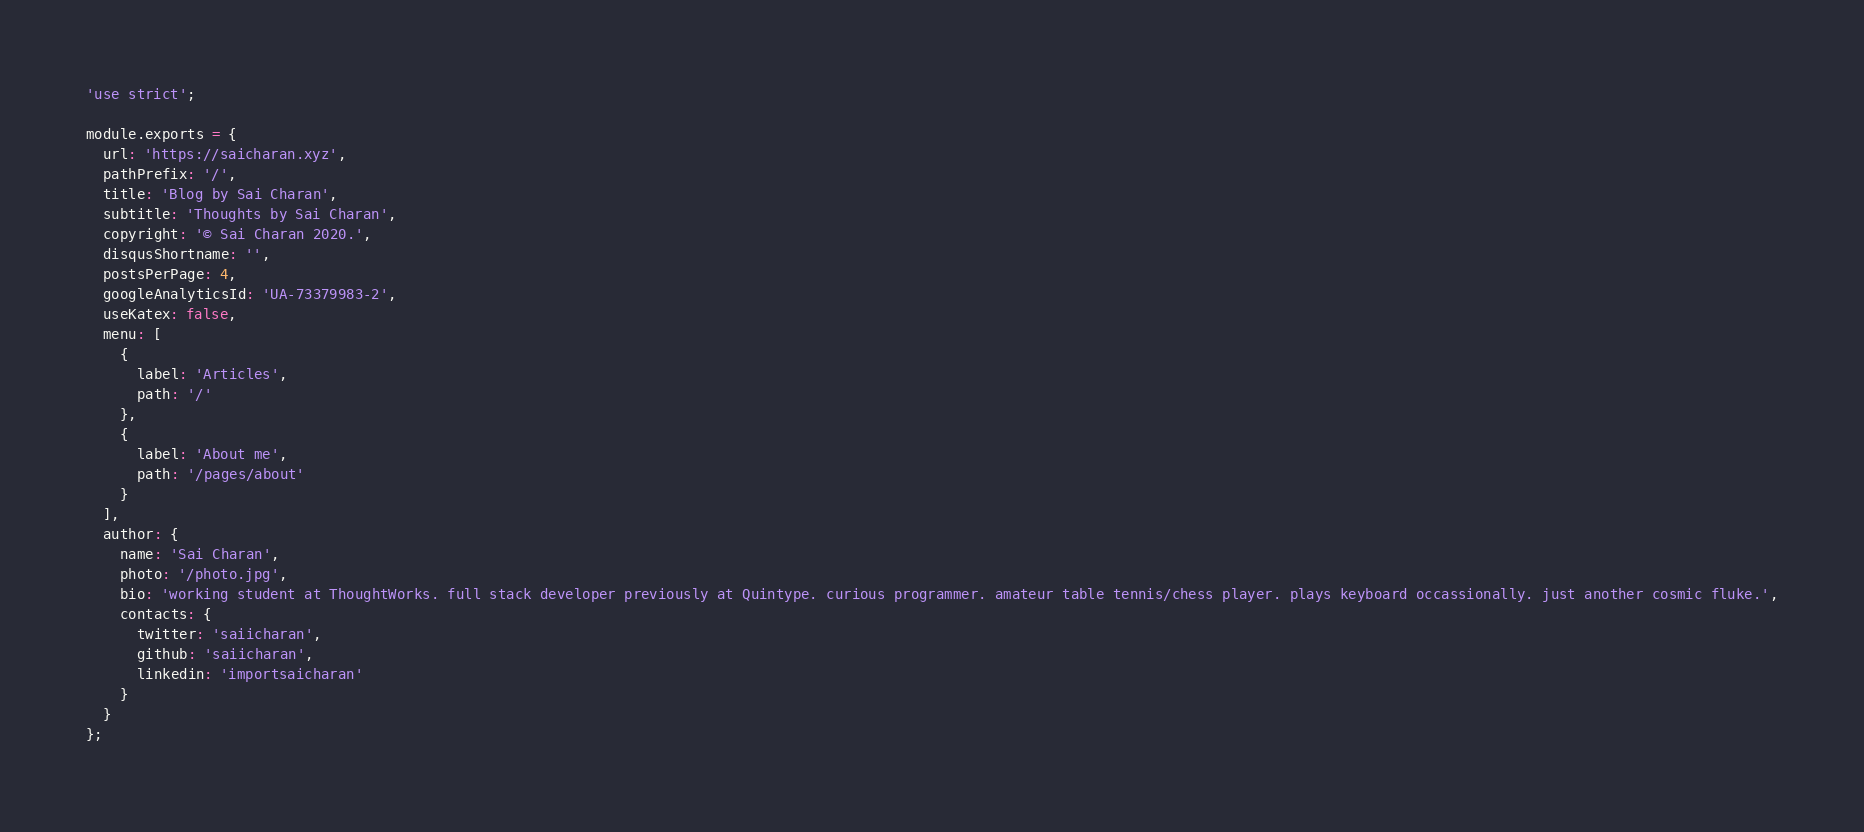Convert code to text. <code><loc_0><loc_0><loc_500><loc_500><_JavaScript_>'use strict';

module.exports = {
  url: 'https://saicharan.xyz',
  pathPrefix: '/',
  title: 'Blog by Sai Charan',
  subtitle: 'Thoughts by Sai Charan',
  copyright: '© Sai Charan 2020.',
  disqusShortname: '',
  postsPerPage: 4,
  googleAnalyticsId: 'UA-73379983-2',
  useKatex: false,
  menu: [
    {
      label: 'Articles',
      path: '/'
    },
    {
      label: 'About me',
      path: '/pages/about'
    }
  ],
  author: {
    name: 'Sai Charan',
    photo: '/photo.jpg',
    bio: 'working student at ThoughtWorks. full stack developer previously at Quintype. curious programmer. amateur table tennis/chess player. plays keyboard occassionally. just another cosmic fluke.',
    contacts: {
      twitter: 'saiicharan',
      github: 'saiicharan',
      linkedin: 'importsaicharan'
    }
  }
};
</code> 